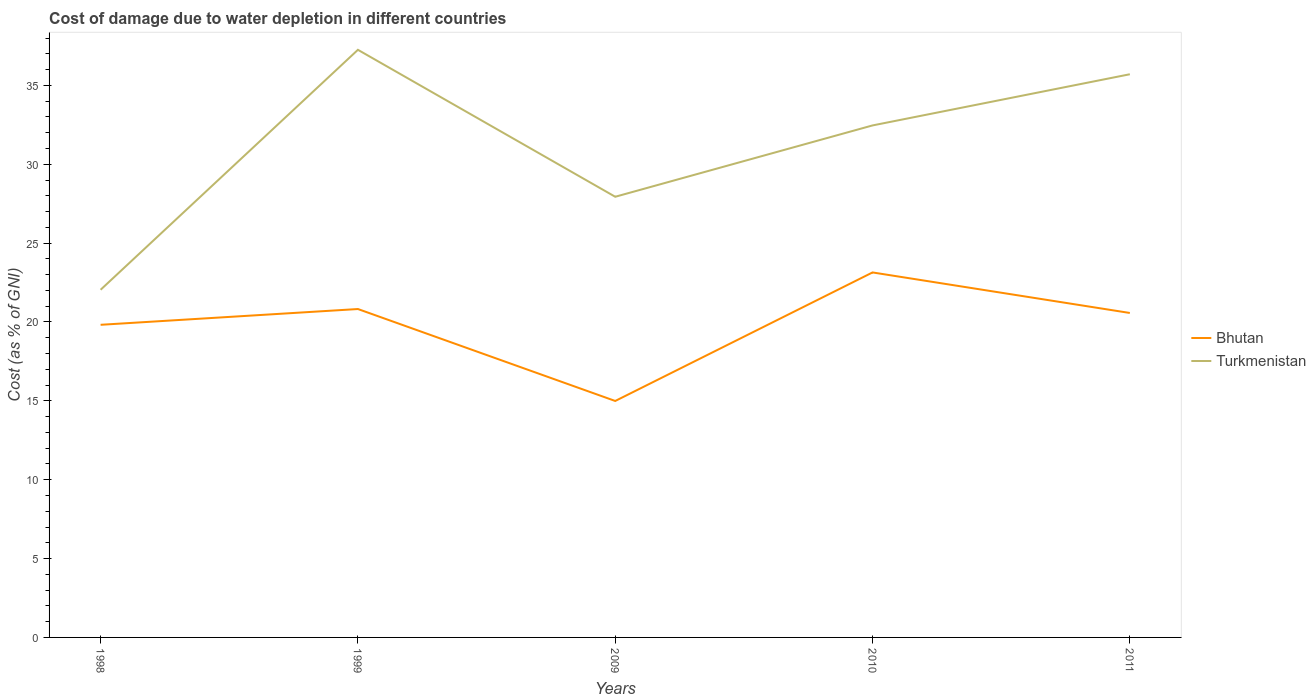How many different coloured lines are there?
Make the answer very short. 2. Does the line corresponding to Bhutan intersect with the line corresponding to Turkmenistan?
Provide a succinct answer. No. Is the number of lines equal to the number of legend labels?
Give a very brief answer. Yes. Across all years, what is the maximum cost of damage caused due to water depletion in Turkmenistan?
Give a very brief answer. 22.04. In which year was the cost of damage caused due to water depletion in Turkmenistan maximum?
Provide a short and direct response. 1998. What is the total cost of damage caused due to water depletion in Bhutan in the graph?
Your answer should be very brief. -8.15. What is the difference between the highest and the second highest cost of damage caused due to water depletion in Bhutan?
Offer a terse response. 8.15. What is the difference between the highest and the lowest cost of damage caused due to water depletion in Turkmenistan?
Provide a short and direct response. 3. How many years are there in the graph?
Offer a terse response. 5. Does the graph contain grids?
Your answer should be very brief. No. What is the title of the graph?
Make the answer very short. Cost of damage due to water depletion in different countries. What is the label or title of the X-axis?
Ensure brevity in your answer.  Years. What is the label or title of the Y-axis?
Your answer should be very brief. Cost (as % of GNI). What is the Cost (as % of GNI) in Bhutan in 1998?
Offer a terse response. 19.82. What is the Cost (as % of GNI) in Turkmenistan in 1998?
Your response must be concise. 22.04. What is the Cost (as % of GNI) of Bhutan in 1999?
Ensure brevity in your answer.  20.82. What is the Cost (as % of GNI) of Turkmenistan in 1999?
Give a very brief answer. 37.25. What is the Cost (as % of GNI) in Bhutan in 2009?
Provide a short and direct response. 14.99. What is the Cost (as % of GNI) in Turkmenistan in 2009?
Ensure brevity in your answer.  27.94. What is the Cost (as % of GNI) of Bhutan in 2010?
Give a very brief answer. 23.14. What is the Cost (as % of GNI) of Turkmenistan in 2010?
Your answer should be very brief. 32.46. What is the Cost (as % of GNI) in Bhutan in 2011?
Your response must be concise. 20.57. What is the Cost (as % of GNI) of Turkmenistan in 2011?
Your answer should be very brief. 35.7. Across all years, what is the maximum Cost (as % of GNI) in Bhutan?
Your response must be concise. 23.14. Across all years, what is the maximum Cost (as % of GNI) of Turkmenistan?
Give a very brief answer. 37.25. Across all years, what is the minimum Cost (as % of GNI) in Bhutan?
Offer a terse response. 14.99. Across all years, what is the minimum Cost (as % of GNI) of Turkmenistan?
Provide a short and direct response. 22.04. What is the total Cost (as % of GNI) in Bhutan in the graph?
Your answer should be very brief. 99.34. What is the total Cost (as % of GNI) of Turkmenistan in the graph?
Your answer should be very brief. 155.4. What is the difference between the Cost (as % of GNI) of Bhutan in 1998 and that in 1999?
Ensure brevity in your answer.  -1. What is the difference between the Cost (as % of GNI) of Turkmenistan in 1998 and that in 1999?
Your answer should be compact. -15.21. What is the difference between the Cost (as % of GNI) of Bhutan in 1998 and that in 2009?
Make the answer very short. 4.83. What is the difference between the Cost (as % of GNI) in Turkmenistan in 1998 and that in 2009?
Provide a succinct answer. -5.9. What is the difference between the Cost (as % of GNI) in Bhutan in 1998 and that in 2010?
Give a very brief answer. -3.32. What is the difference between the Cost (as % of GNI) in Turkmenistan in 1998 and that in 2010?
Ensure brevity in your answer.  -10.42. What is the difference between the Cost (as % of GNI) of Bhutan in 1998 and that in 2011?
Give a very brief answer. -0.75. What is the difference between the Cost (as % of GNI) of Turkmenistan in 1998 and that in 2011?
Make the answer very short. -13.66. What is the difference between the Cost (as % of GNI) in Bhutan in 1999 and that in 2009?
Keep it short and to the point. 5.83. What is the difference between the Cost (as % of GNI) in Turkmenistan in 1999 and that in 2009?
Keep it short and to the point. 9.32. What is the difference between the Cost (as % of GNI) in Bhutan in 1999 and that in 2010?
Give a very brief answer. -2.32. What is the difference between the Cost (as % of GNI) of Turkmenistan in 1999 and that in 2010?
Offer a very short reply. 4.79. What is the difference between the Cost (as % of GNI) in Bhutan in 1999 and that in 2011?
Offer a terse response. 0.25. What is the difference between the Cost (as % of GNI) in Turkmenistan in 1999 and that in 2011?
Offer a very short reply. 1.55. What is the difference between the Cost (as % of GNI) of Bhutan in 2009 and that in 2010?
Give a very brief answer. -8.15. What is the difference between the Cost (as % of GNI) of Turkmenistan in 2009 and that in 2010?
Provide a short and direct response. -4.52. What is the difference between the Cost (as % of GNI) in Bhutan in 2009 and that in 2011?
Provide a short and direct response. -5.58. What is the difference between the Cost (as % of GNI) in Turkmenistan in 2009 and that in 2011?
Give a very brief answer. -7.77. What is the difference between the Cost (as % of GNI) of Bhutan in 2010 and that in 2011?
Your answer should be very brief. 2.57. What is the difference between the Cost (as % of GNI) in Turkmenistan in 2010 and that in 2011?
Your response must be concise. -3.25. What is the difference between the Cost (as % of GNI) in Bhutan in 1998 and the Cost (as % of GNI) in Turkmenistan in 1999?
Your response must be concise. -17.43. What is the difference between the Cost (as % of GNI) in Bhutan in 1998 and the Cost (as % of GNI) in Turkmenistan in 2009?
Provide a succinct answer. -8.12. What is the difference between the Cost (as % of GNI) of Bhutan in 1998 and the Cost (as % of GNI) of Turkmenistan in 2010?
Offer a terse response. -12.64. What is the difference between the Cost (as % of GNI) of Bhutan in 1998 and the Cost (as % of GNI) of Turkmenistan in 2011?
Make the answer very short. -15.88. What is the difference between the Cost (as % of GNI) in Bhutan in 1999 and the Cost (as % of GNI) in Turkmenistan in 2009?
Make the answer very short. -7.12. What is the difference between the Cost (as % of GNI) of Bhutan in 1999 and the Cost (as % of GNI) of Turkmenistan in 2010?
Give a very brief answer. -11.64. What is the difference between the Cost (as % of GNI) in Bhutan in 1999 and the Cost (as % of GNI) in Turkmenistan in 2011?
Ensure brevity in your answer.  -14.88. What is the difference between the Cost (as % of GNI) in Bhutan in 2009 and the Cost (as % of GNI) in Turkmenistan in 2010?
Provide a short and direct response. -17.47. What is the difference between the Cost (as % of GNI) in Bhutan in 2009 and the Cost (as % of GNI) in Turkmenistan in 2011?
Ensure brevity in your answer.  -20.71. What is the difference between the Cost (as % of GNI) in Bhutan in 2010 and the Cost (as % of GNI) in Turkmenistan in 2011?
Give a very brief answer. -12.57. What is the average Cost (as % of GNI) of Bhutan per year?
Ensure brevity in your answer.  19.87. What is the average Cost (as % of GNI) of Turkmenistan per year?
Your response must be concise. 31.08. In the year 1998, what is the difference between the Cost (as % of GNI) in Bhutan and Cost (as % of GNI) in Turkmenistan?
Provide a succinct answer. -2.22. In the year 1999, what is the difference between the Cost (as % of GNI) of Bhutan and Cost (as % of GNI) of Turkmenistan?
Provide a succinct answer. -16.43. In the year 2009, what is the difference between the Cost (as % of GNI) in Bhutan and Cost (as % of GNI) in Turkmenistan?
Your answer should be very brief. -12.95. In the year 2010, what is the difference between the Cost (as % of GNI) in Bhutan and Cost (as % of GNI) in Turkmenistan?
Give a very brief answer. -9.32. In the year 2011, what is the difference between the Cost (as % of GNI) of Bhutan and Cost (as % of GNI) of Turkmenistan?
Your answer should be compact. -15.13. What is the ratio of the Cost (as % of GNI) of Bhutan in 1998 to that in 1999?
Ensure brevity in your answer.  0.95. What is the ratio of the Cost (as % of GNI) in Turkmenistan in 1998 to that in 1999?
Ensure brevity in your answer.  0.59. What is the ratio of the Cost (as % of GNI) of Bhutan in 1998 to that in 2009?
Your response must be concise. 1.32. What is the ratio of the Cost (as % of GNI) in Turkmenistan in 1998 to that in 2009?
Your response must be concise. 0.79. What is the ratio of the Cost (as % of GNI) in Bhutan in 1998 to that in 2010?
Provide a succinct answer. 0.86. What is the ratio of the Cost (as % of GNI) of Turkmenistan in 1998 to that in 2010?
Give a very brief answer. 0.68. What is the ratio of the Cost (as % of GNI) of Bhutan in 1998 to that in 2011?
Give a very brief answer. 0.96. What is the ratio of the Cost (as % of GNI) in Turkmenistan in 1998 to that in 2011?
Offer a very short reply. 0.62. What is the ratio of the Cost (as % of GNI) in Bhutan in 1999 to that in 2009?
Your response must be concise. 1.39. What is the ratio of the Cost (as % of GNI) of Turkmenistan in 1999 to that in 2009?
Offer a terse response. 1.33. What is the ratio of the Cost (as % of GNI) of Bhutan in 1999 to that in 2010?
Give a very brief answer. 0.9. What is the ratio of the Cost (as % of GNI) in Turkmenistan in 1999 to that in 2010?
Keep it short and to the point. 1.15. What is the ratio of the Cost (as % of GNI) of Bhutan in 1999 to that in 2011?
Ensure brevity in your answer.  1.01. What is the ratio of the Cost (as % of GNI) in Turkmenistan in 1999 to that in 2011?
Provide a succinct answer. 1.04. What is the ratio of the Cost (as % of GNI) in Bhutan in 2009 to that in 2010?
Make the answer very short. 0.65. What is the ratio of the Cost (as % of GNI) in Turkmenistan in 2009 to that in 2010?
Provide a succinct answer. 0.86. What is the ratio of the Cost (as % of GNI) in Bhutan in 2009 to that in 2011?
Provide a succinct answer. 0.73. What is the ratio of the Cost (as % of GNI) in Turkmenistan in 2009 to that in 2011?
Your answer should be very brief. 0.78. What is the ratio of the Cost (as % of GNI) of Bhutan in 2010 to that in 2011?
Provide a short and direct response. 1.12. What is the ratio of the Cost (as % of GNI) in Turkmenistan in 2010 to that in 2011?
Make the answer very short. 0.91. What is the difference between the highest and the second highest Cost (as % of GNI) in Bhutan?
Keep it short and to the point. 2.32. What is the difference between the highest and the second highest Cost (as % of GNI) of Turkmenistan?
Your answer should be compact. 1.55. What is the difference between the highest and the lowest Cost (as % of GNI) in Bhutan?
Provide a short and direct response. 8.15. What is the difference between the highest and the lowest Cost (as % of GNI) in Turkmenistan?
Provide a succinct answer. 15.21. 